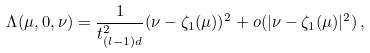Convert formula to latex. <formula><loc_0><loc_0><loc_500><loc_500>\Lambda ( \mu , 0 , \nu ) = \frac { 1 } { t _ { ( l - 1 ) d } ^ { 2 } } ( \nu - \zeta _ { 1 } ( \mu ) ) ^ { 2 } + o ( | \nu - \zeta _ { 1 } ( \mu ) | ^ { 2 } ) \, ,</formula> 